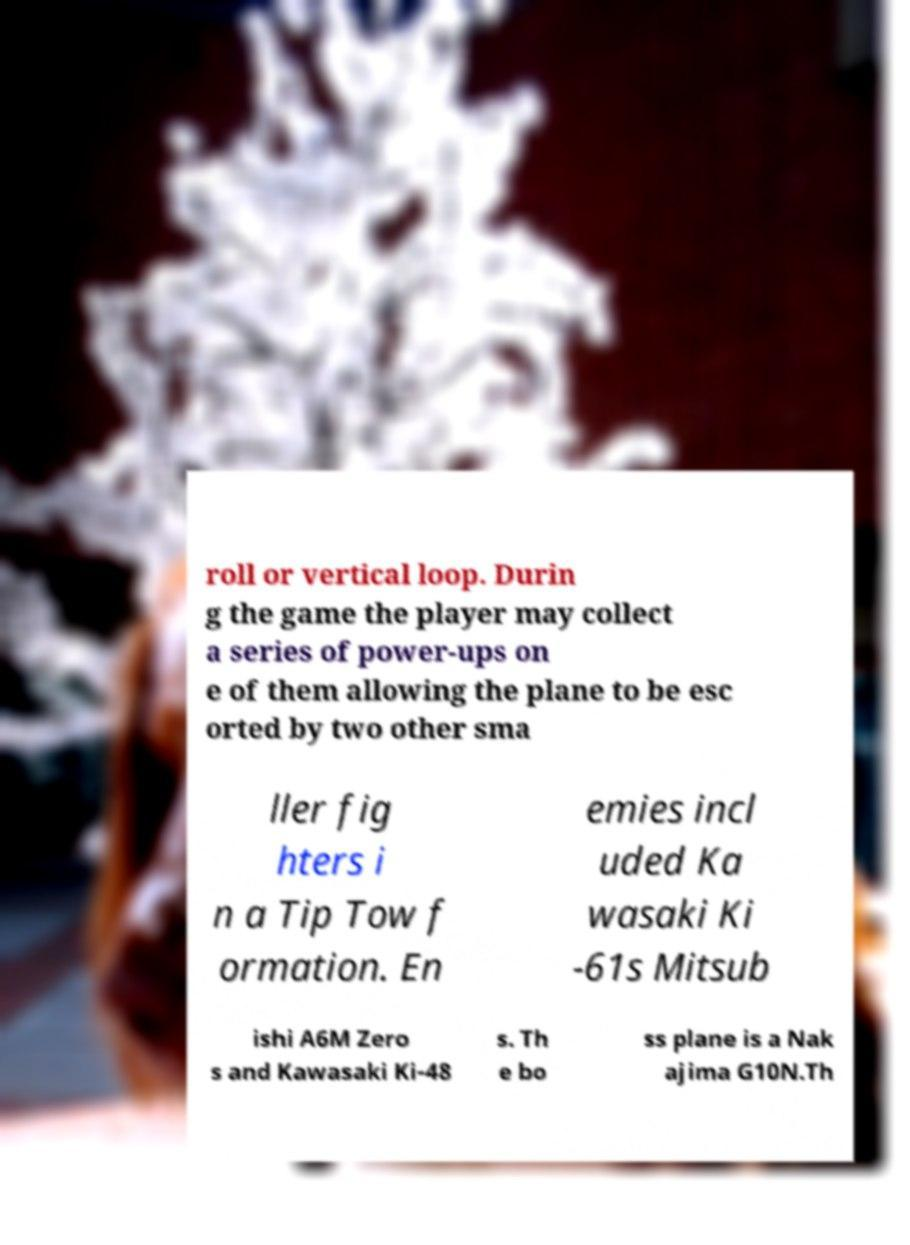Please read and relay the text visible in this image. What does it say? roll or vertical loop. Durin g the game the player may collect a series of power-ups on e of them allowing the plane to be esc orted by two other sma ller fig hters i n a Tip Tow f ormation. En emies incl uded Ka wasaki Ki -61s Mitsub ishi A6M Zero s and Kawasaki Ki-48 s. Th e bo ss plane is a Nak ajima G10N.Th 